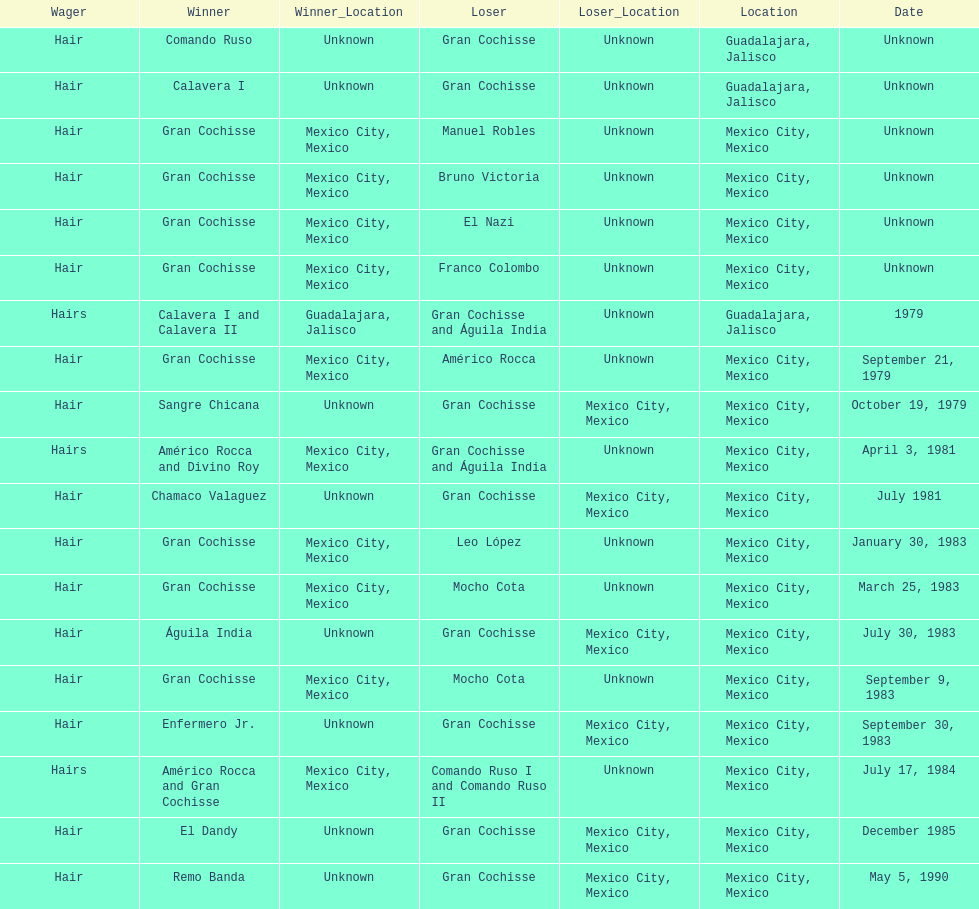When was gran chochisse first match that had a full date on record? September 21, 1979. 